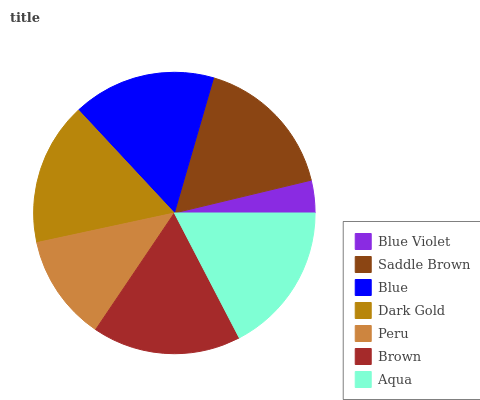Is Blue Violet the minimum?
Answer yes or no. Yes. Is Aqua the maximum?
Answer yes or no. Yes. Is Saddle Brown the minimum?
Answer yes or no. No. Is Saddle Brown the maximum?
Answer yes or no. No. Is Saddle Brown greater than Blue Violet?
Answer yes or no. Yes. Is Blue Violet less than Saddle Brown?
Answer yes or no. Yes. Is Blue Violet greater than Saddle Brown?
Answer yes or no. No. Is Saddle Brown less than Blue Violet?
Answer yes or no. No. Is Dark Gold the high median?
Answer yes or no. Yes. Is Dark Gold the low median?
Answer yes or no. Yes. Is Aqua the high median?
Answer yes or no. No. Is Blue the low median?
Answer yes or no. No. 